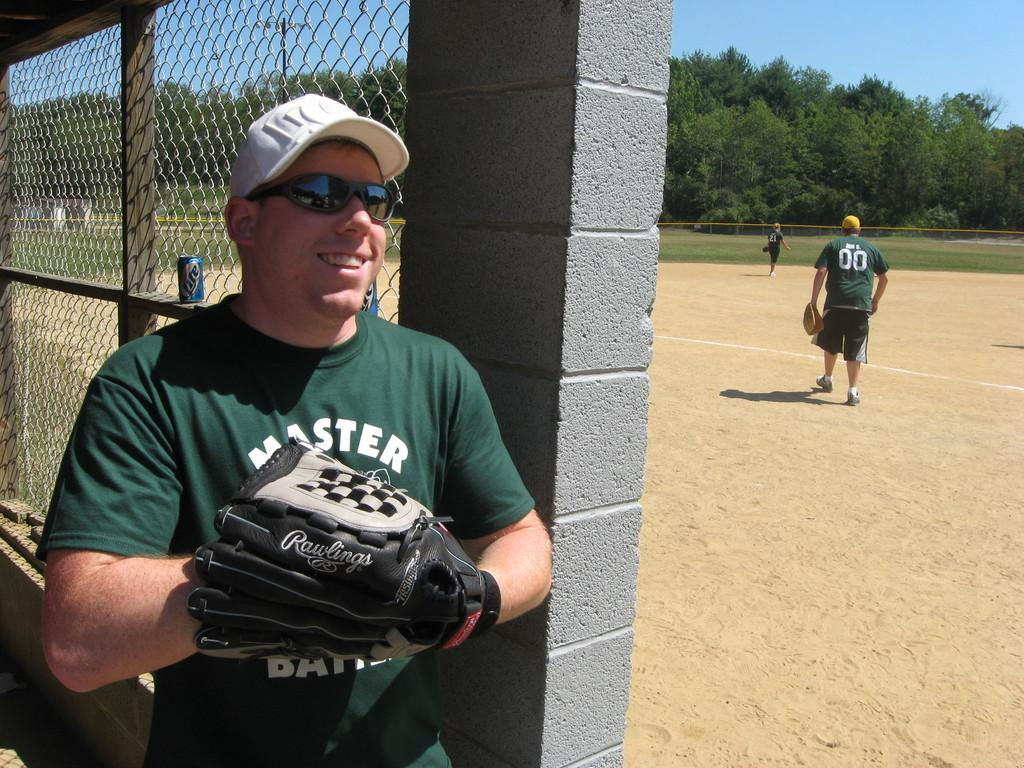<image>
Provide a brief description of the given image. A man in a green Master shirt holding a baseball glove. 